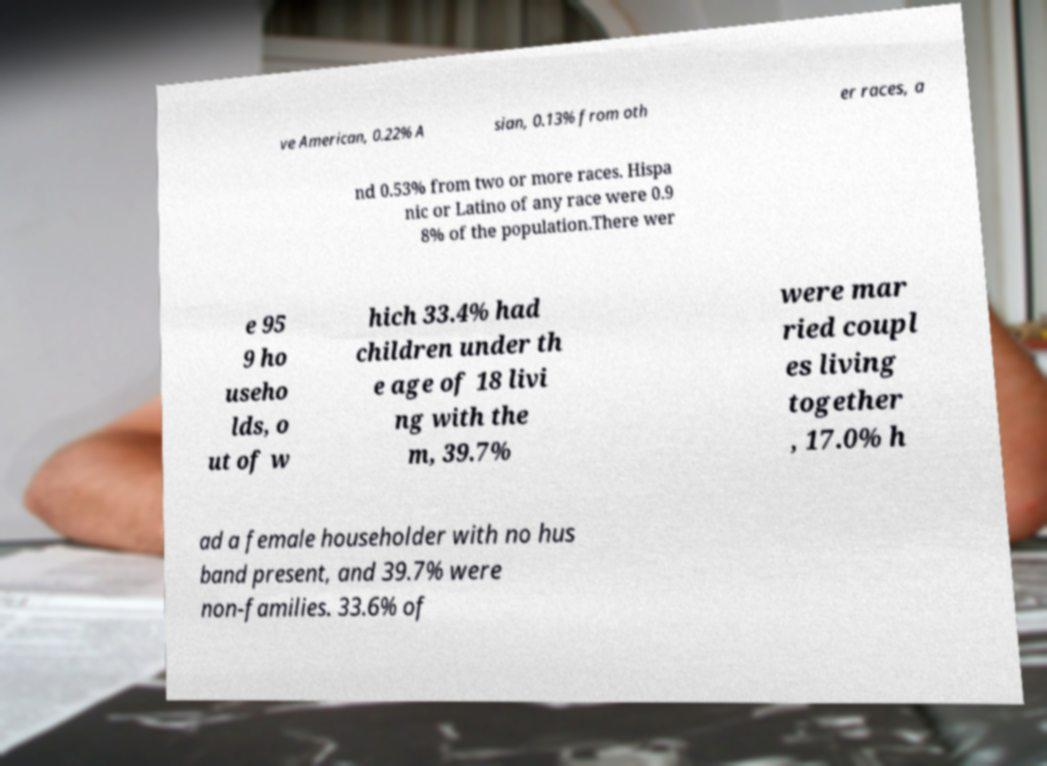Can you accurately transcribe the text from the provided image for me? ve American, 0.22% A sian, 0.13% from oth er races, a nd 0.53% from two or more races. Hispa nic or Latino of any race were 0.9 8% of the population.There wer e 95 9 ho useho lds, o ut of w hich 33.4% had children under th e age of 18 livi ng with the m, 39.7% were mar ried coupl es living together , 17.0% h ad a female householder with no hus band present, and 39.7% were non-families. 33.6% of 